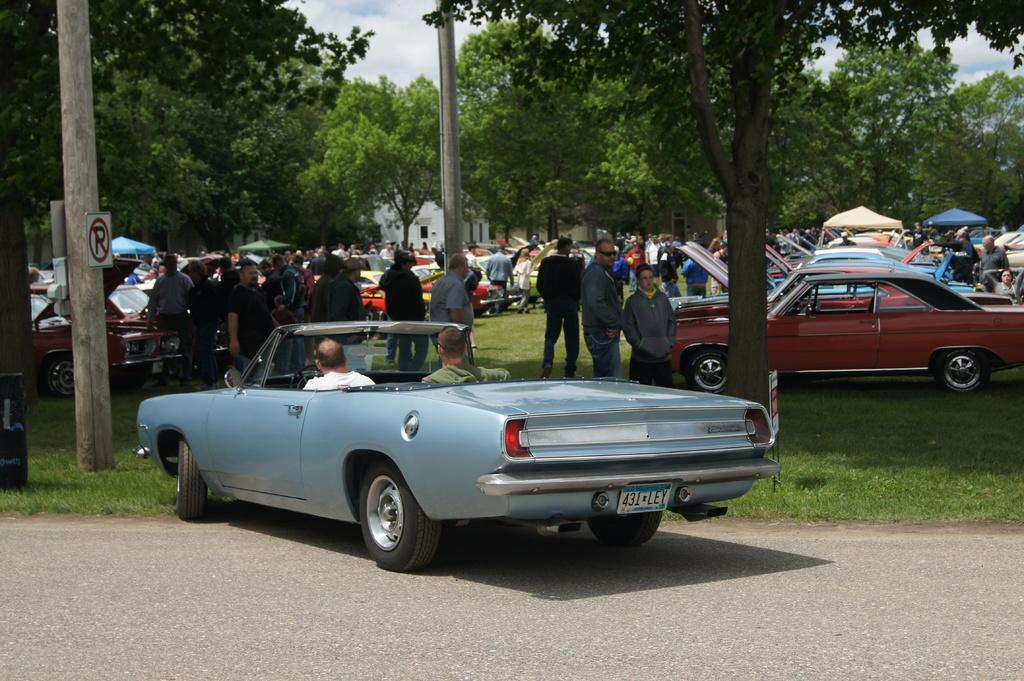What is the setting of the image? The image shows cars parked in a garden. What else can be seen in the garden besides the cars? There are many people around the cars in the image. What is the surrounding environment like in the garden? There are a lot of trees around the garden in the image. What type of mass is being held in the garden in the image? There is no indication of a mass or gathering in the image; it simply shows cars parked in a garden with people around them. 